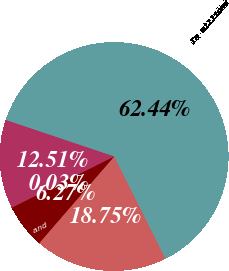Convert chart. <chart><loc_0><loc_0><loc_500><loc_500><pie_chart><fcel>In millions<fcel>January 1<fcel>Reserve adjustments net<fcel>Losses - loan repurchases and<fcel>December 31<nl><fcel>62.43%<fcel>18.75%<fcel>6.27%<fcel>0.03%<fcel>12.51%<nl></chart> 